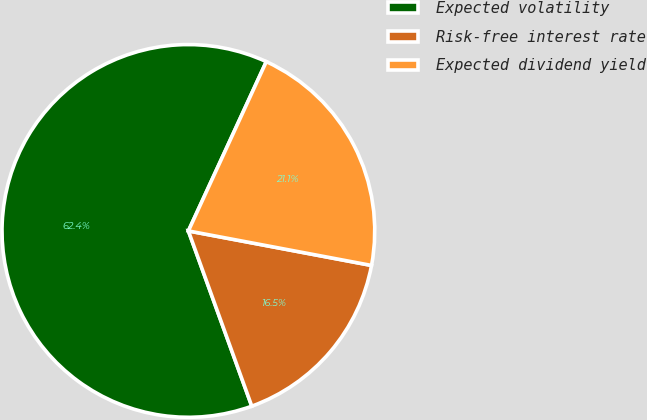<chart> <loc_0><loc_0><loc_500><loc_500><pie_chart><fcel>Expected volatility<fcel>Risk-free interest rate<fcel>Expected dividend yield<nl><fcel>62.39%<fcel>16.51%<fcel>21.1%<nl></chart> 